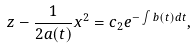<formula> <loc_0><loc_0><loc_500><loc_500>z - \frac { 1 } { 2 a ( t ) } x ^ { 2 } = c _ { 2 } e ^ { - \int b ( t ) d t } ,</formula> 